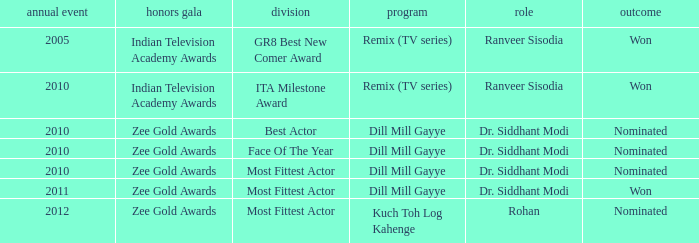Which show has a character of Rohan? Kuch Toh Log Kahenge. 